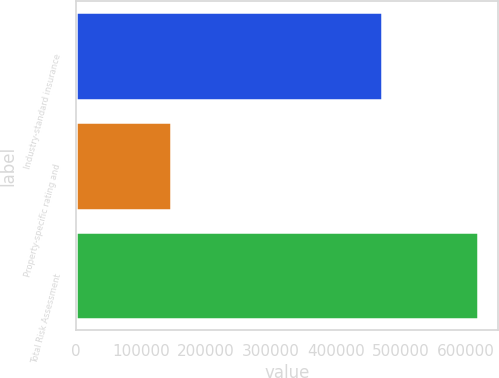<chart> <loc_0><loc_0><loc_500><loc_500><bar_chart><fcel>Industry-standard insurance<fcel>Property-specific rating and<fcel>Total Risk Assessment<nl><fcel>471130<fcel>147146<fcel>618276<nl></chart> 